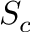Convert formula to latex. <formula><loc_0><loc_0><loc_500><loc_500>S _ { c }</formula> 